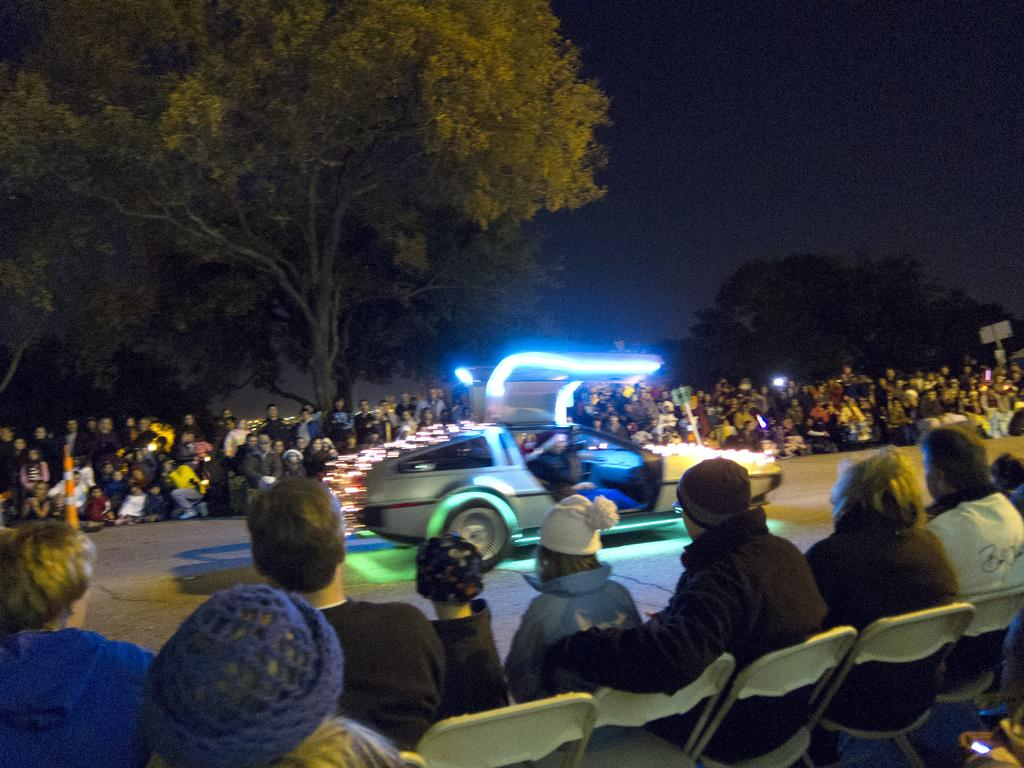What is on the road in the image? There is a vehicle on the road in the image. What are the people in the image doing? There are people sitting on chairs in the image. Can you describe the setting in the image? There is a crowd visible in the image, and trees are present. What can be seen in the image that might provide illumination? There are lights in the image. What object in the image might be used for displaying information or advertisements? There is a board in the image. What safety feature is visible in the image? A traffic cone is visible in the image. What type of tree is growing on the board in the image? There is no tree growing on the board in the image; it is a flat surface meant for displaying information or advertisements. What texture can be seen on the traffic cone in the image? The traffic cone in the image is a solid object and does not have a texture. 